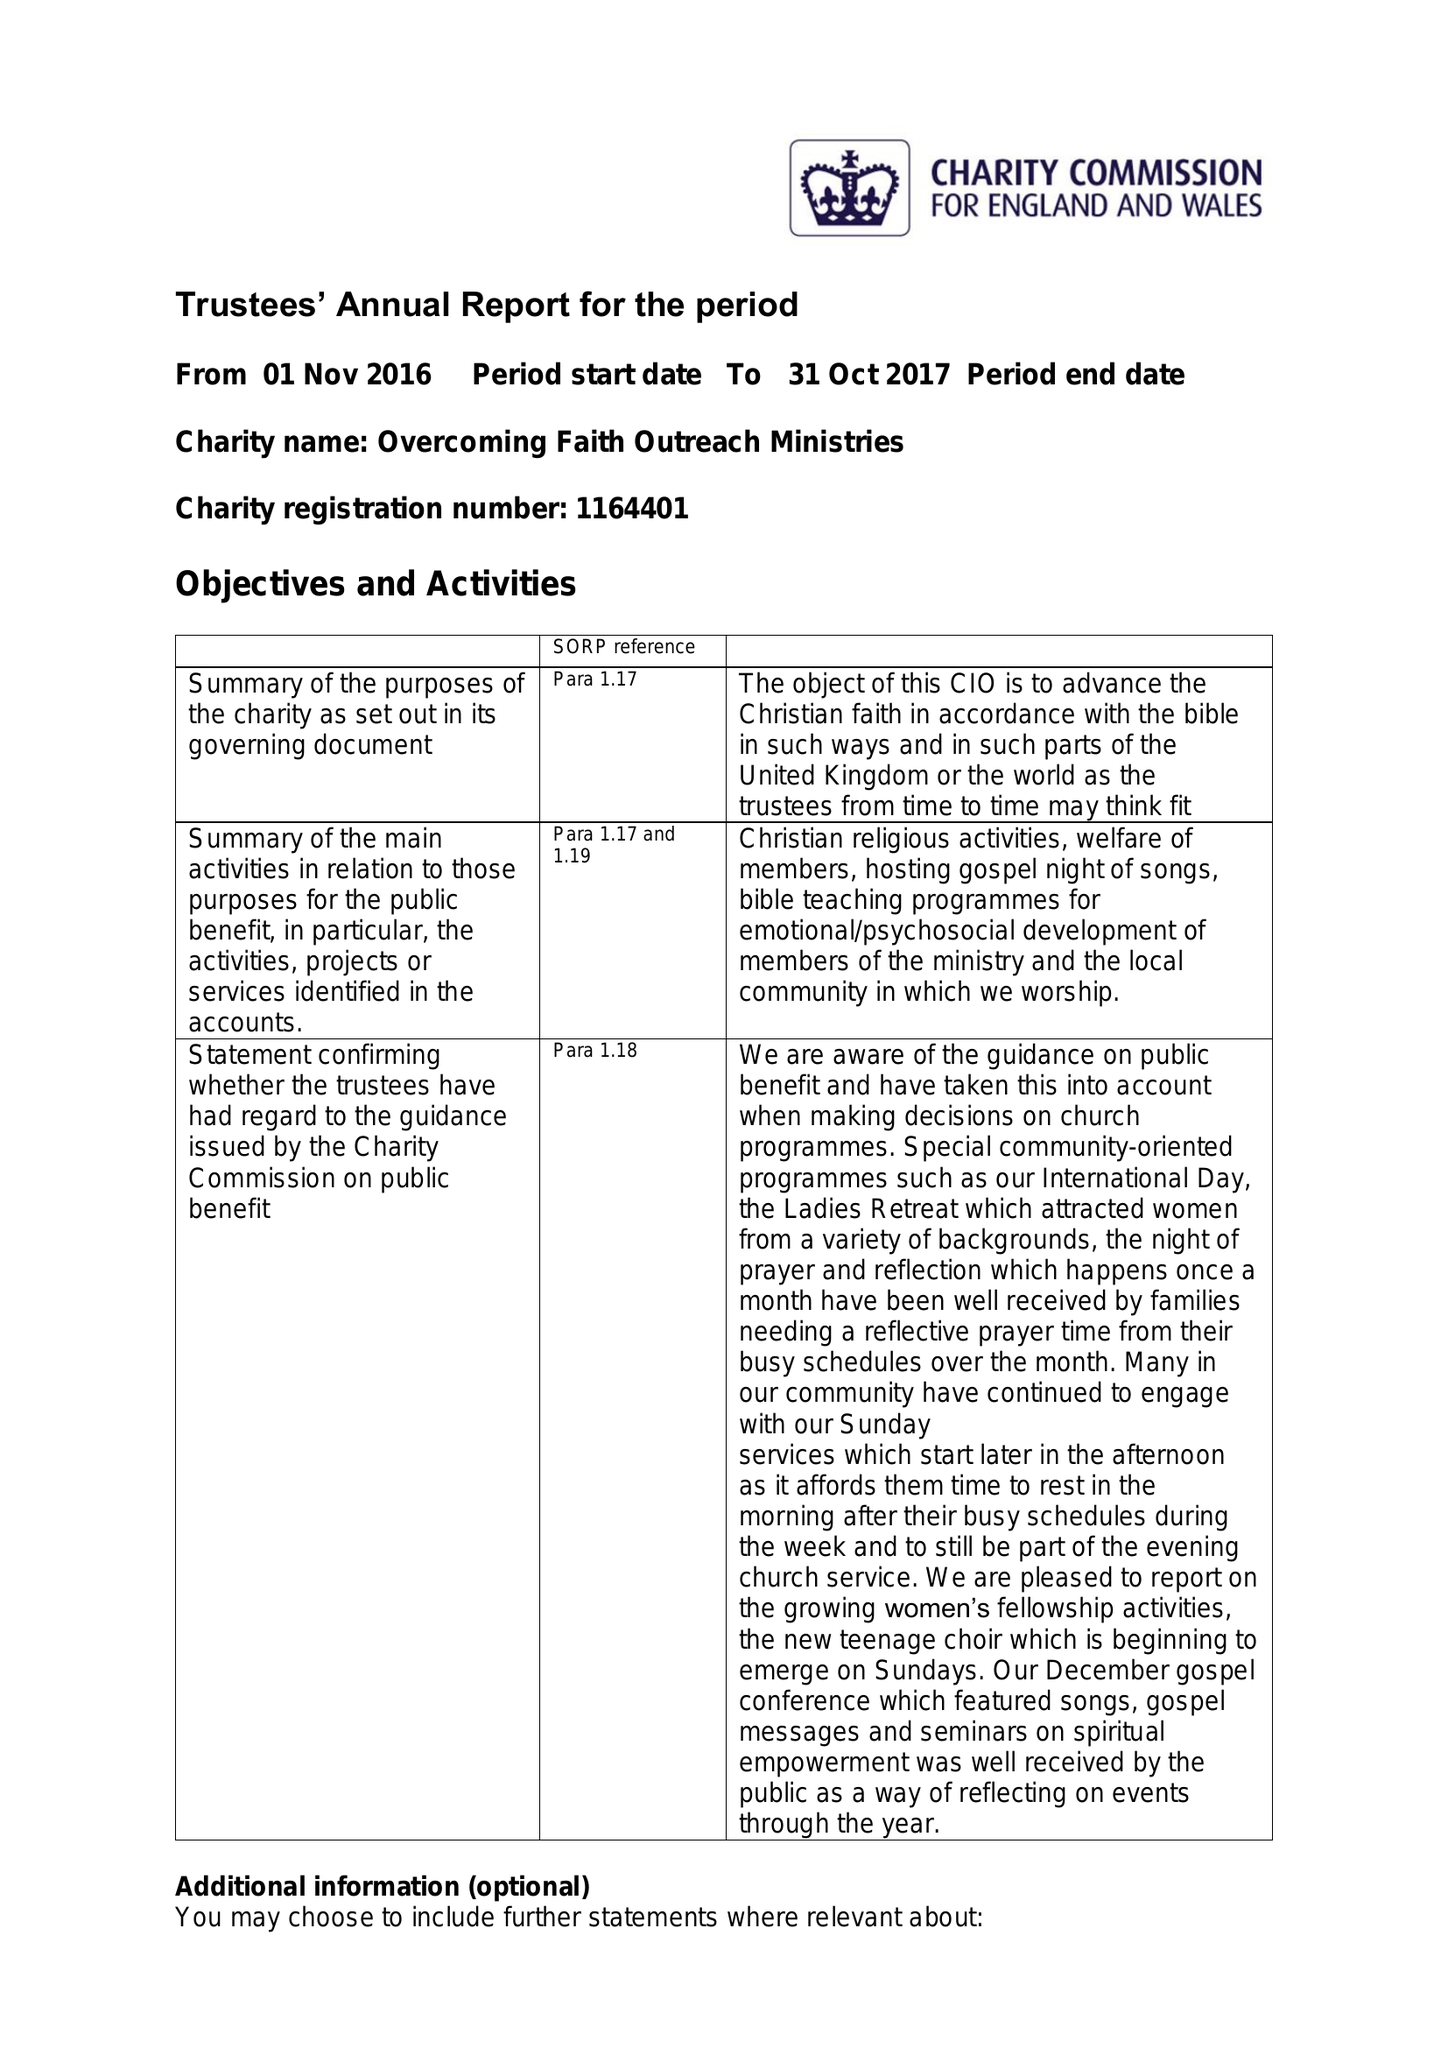What is the value for the address__post_town?
Answer the question using a single word or phrase. ROMFORD 